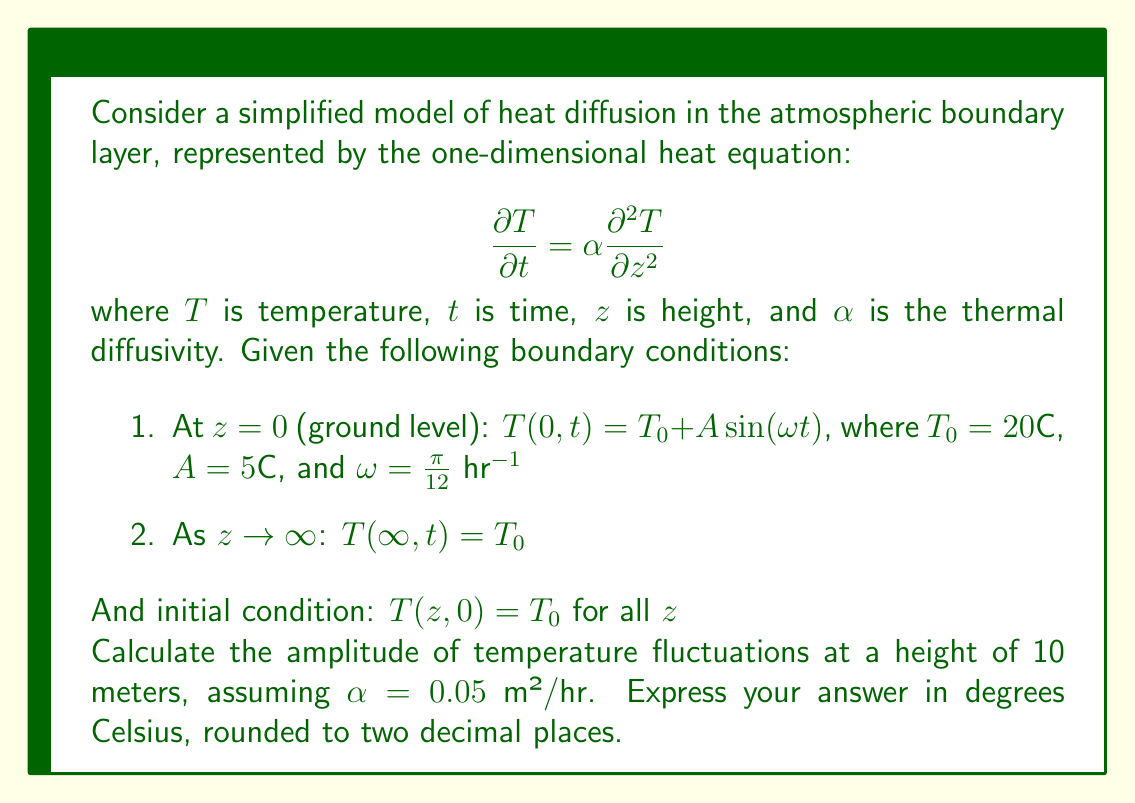Could you help me with this problem? To solve this problem, we need to follow these steps:

1) The general solution for this heat equation with periodic boundary conditions is:

   $$T(z,t) = T_0 + A e^{-kz} \sin(\omega t - kz)$$

   where $k = \sqrt{\frac{\omega}{2\alpha}}$

2) Calculate $k$:
   $$k = \sqrt{\frac{\omega}{2\alpha}} = \sqrt{\frac{\pi/12}{2(0.05)}} = \sqrt{\frac{\pi}{1.2}} \approx 1.61 \text{ m}^{-1}$$

3) The amplitude of temperature fluctuations at height $z$ is given by $A e^{-kz}$

4) For $z = 10$ m:
   $$A e^{-kz} = 5 e^{-1.61 \cdot 10} = 5 e^{-16.1} \approx 0.0508°C$$

5) Round to two decimal places: 0.05°C

This result shows that the amplitude of temperature fluctuations decreases rapidly with height, which is consistent with the observed behavior in the atmospheric boundary layer.
Answer: 0.05°C 